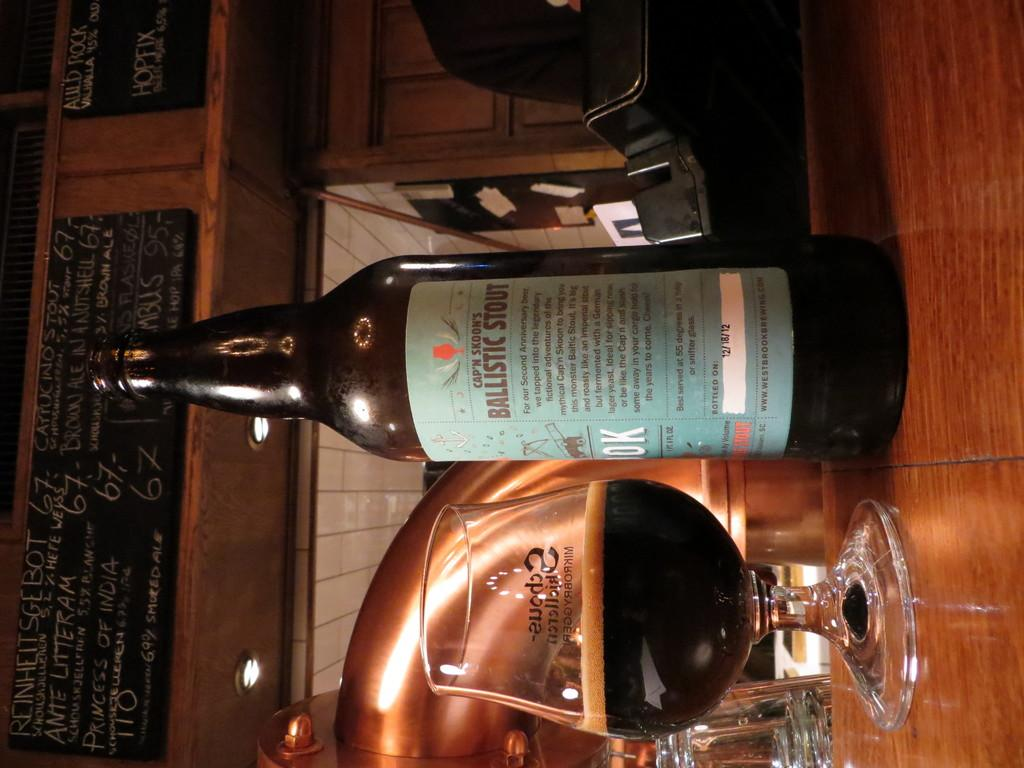<image>
Present a compact description of the photo's key features. the word Ballistic is on a beer bottle 